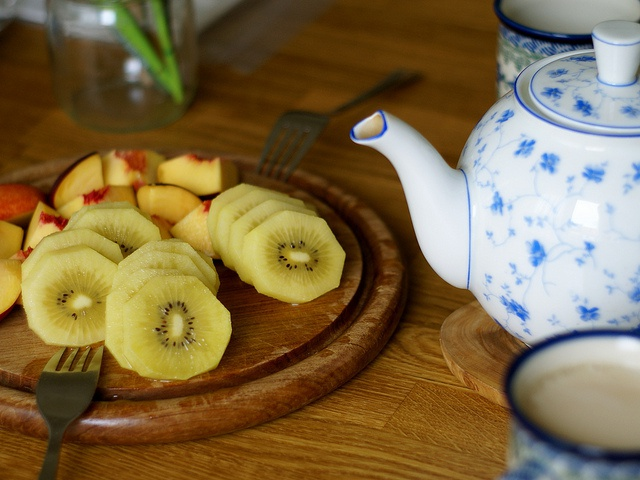Describe the objects in this image and their specific colors. I can see dining table in gray, maroon, olive, and black tones, cup in gray, darkgray, and black tones, bowl in gray, darkgray, and black tones, vase in gray, black, and darkgreen tones, and apple in gray, olive, tan, and orange tones in this image. 